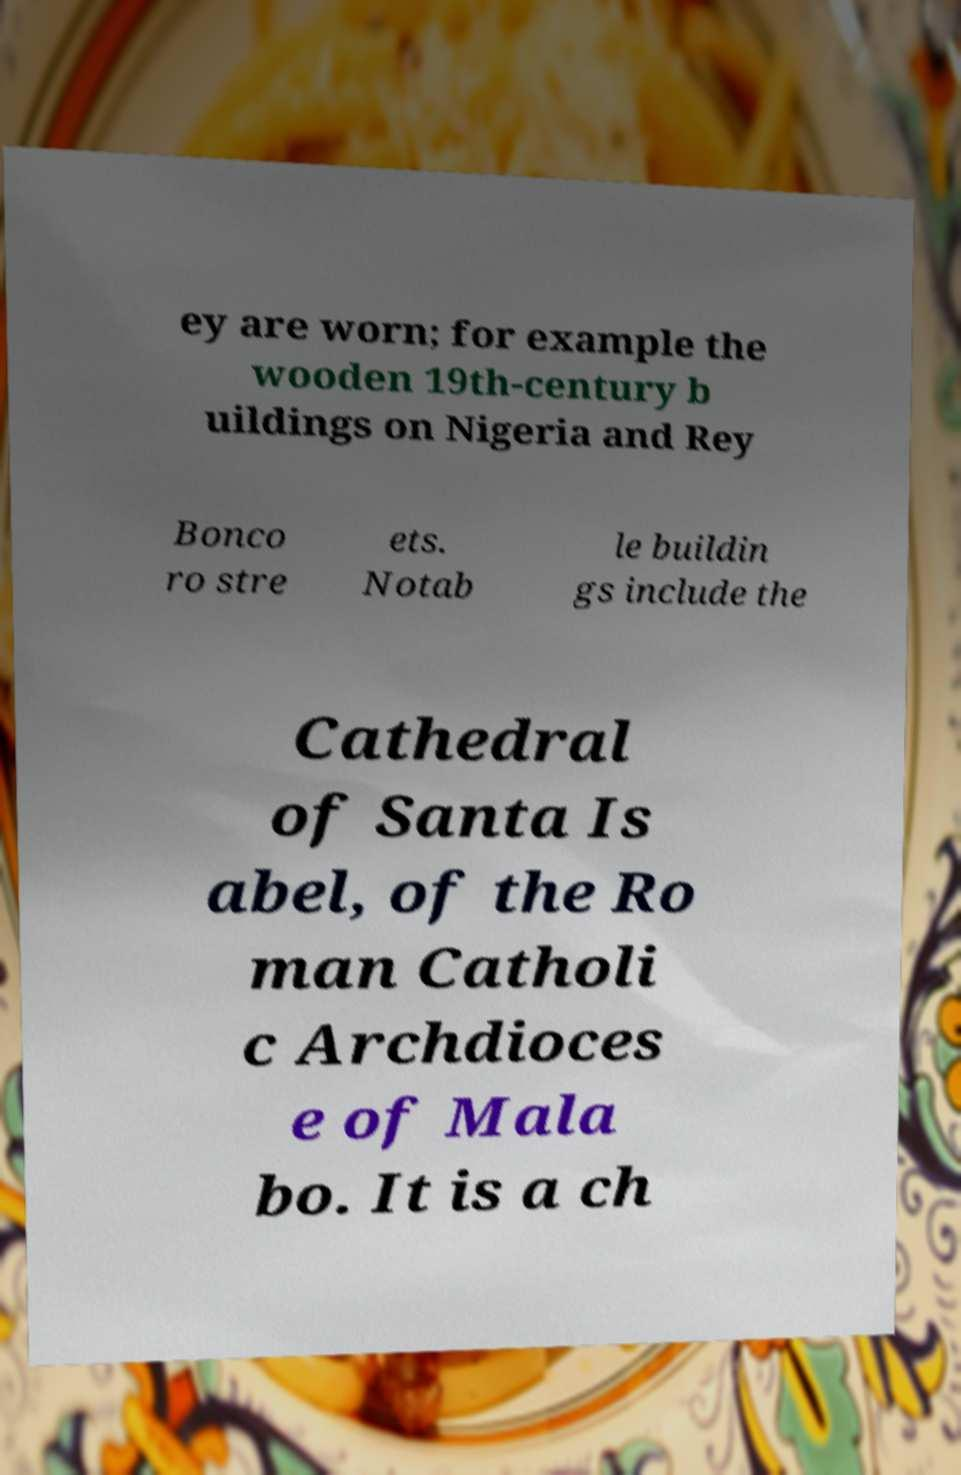Could you extract and type out the text from this image? ey are worn; for example the wooden 19th-century b uildings on Nigeria and Rey Bonco ro stre ets. Notab le buildin gs include the Cathedral of Santa Is abel, of the Ro man Catholi c Archdioces e of Mala bo. It is a ch 